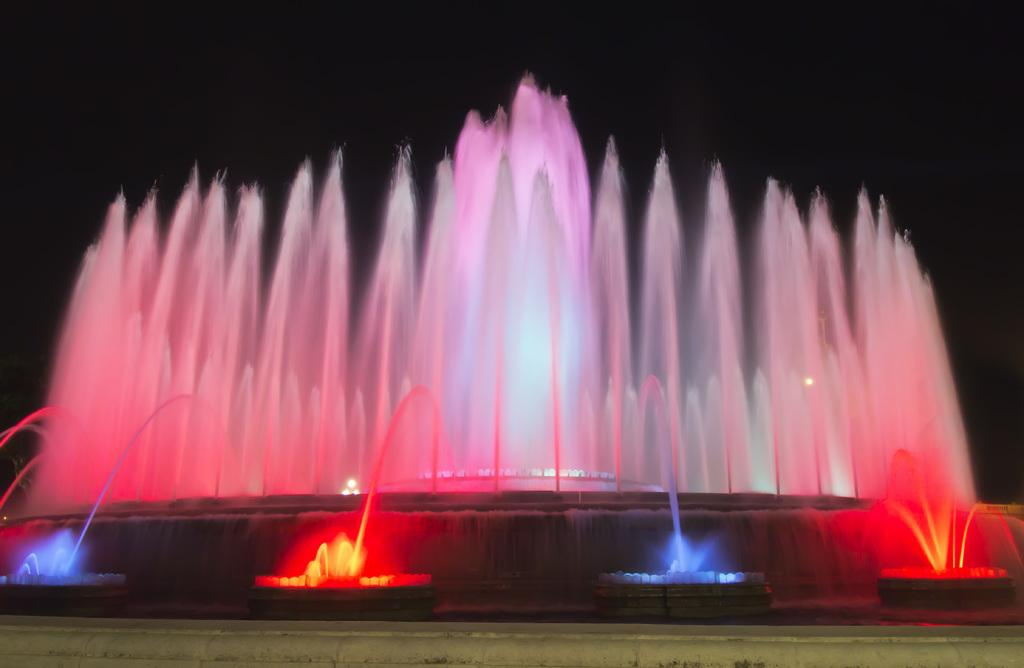What type of feature is present in the image? There are water fountains in the image. What kind of event or show is taking place? It appears to be a light and water show. What is located at the bottom of the image? There is a wall at the bottom of the image. How would you describe the overall lighting in the image? The background of the image is dark. What type of jam is being spread on the hat in the image? There is no jam or hat present in the image. How many shoes can be seen in the image? There are no shoes visible in the image. 